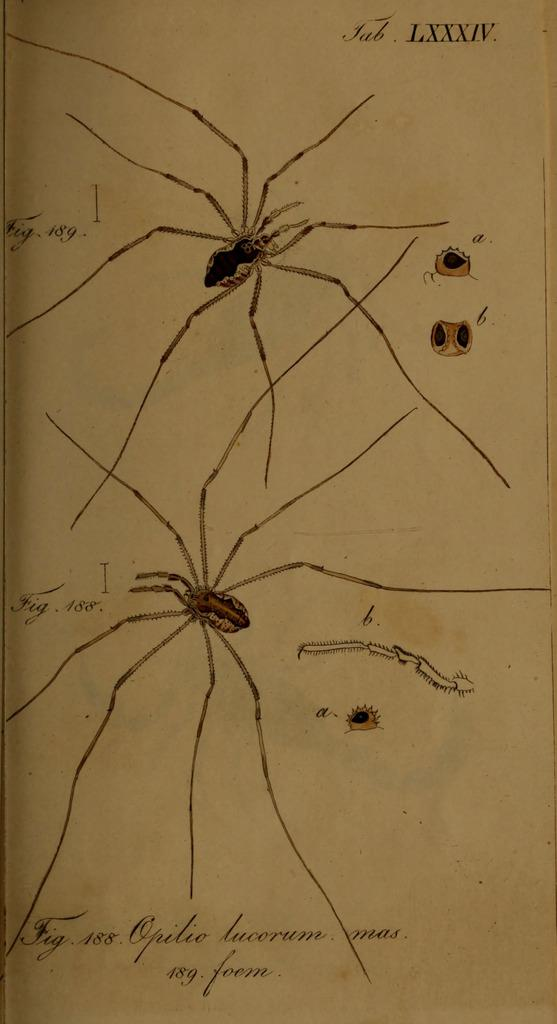How many spiders are present in the image? There are two spiders in the image. What is written above and below the spiders? There is text written above and below the spiders. What type of group activity is the spider participating in with the patch in the image? There is no patch present in the image, and the spiders are not participating in any group activity. 